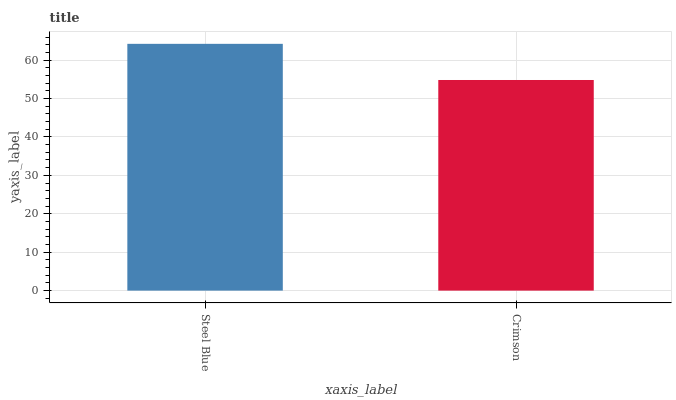Is Crimson the minimum?
Answer yes or no. Yes. Is Steel Blue the maximum?
Answer yes or no. Yes. Is Crimson the maximum?
Answer yes or no. No. Is Steel Blue greater than Crimson?
Answer yes or no. Yes. Is Crimson less than Steel Blue?
Answer yes or no. Yes. Is Crimson greater than Steel Blue?
Answer yes or no. No. Is Steel Blue less than Crimson?
Answer yes or no. No. Is Steel Blue the high median?
Answer yes or no. Yes. Is Crimson the low median?
Answer yes or no. Yes. Is Crimson the high median?
Answer yes or no. No. Is Steel Blue the low median?
Answer yes or no. No. 